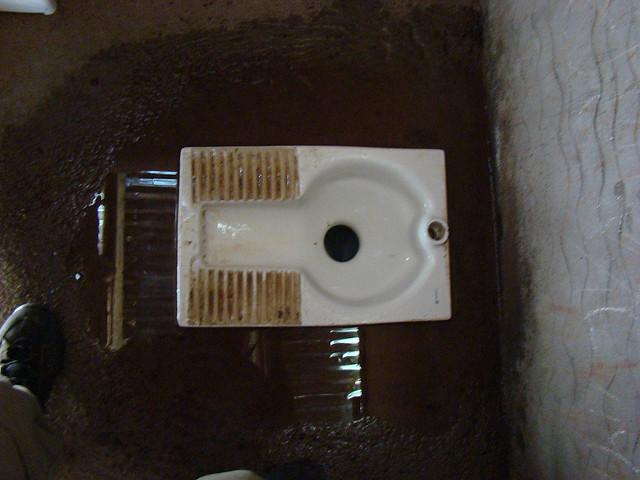Is the object in the room clean?
Give a very brief answer. No. Would you find one of these in America?
Quick response, please. No. What is the white object?
Concise answer only. Toilet. 